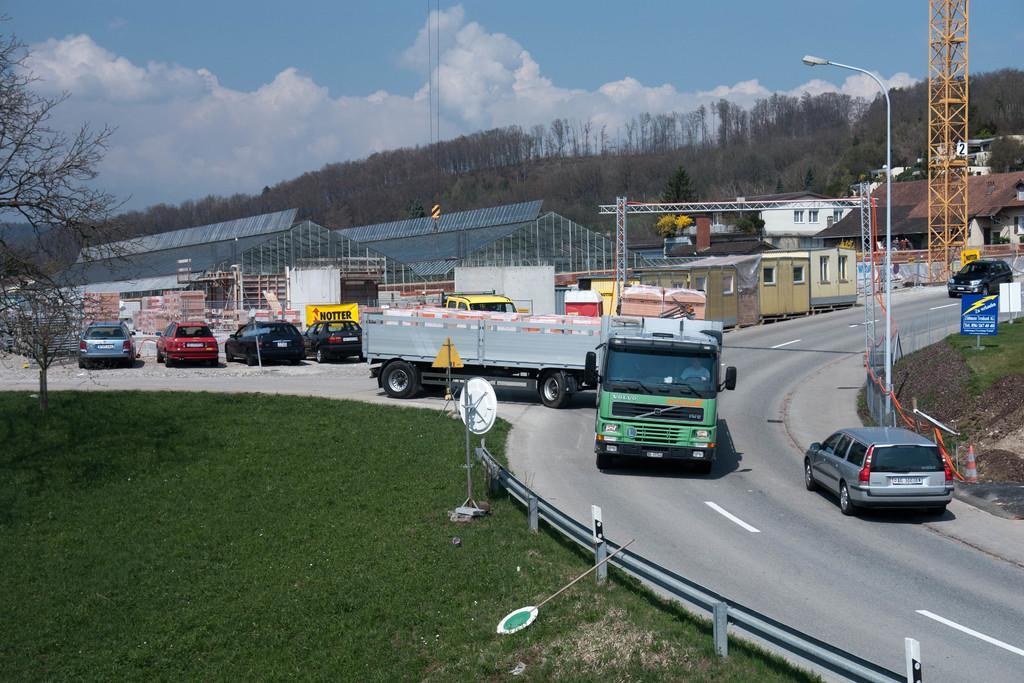How would you summarize this image in a sentence or two? In the foreground, I can see a fence, sign boards, grass, trees and fleets of vehicles on the road. In the background, I can see light poles, metal rods, sheds, buildings and the sky. This picture might be taken in a day. 